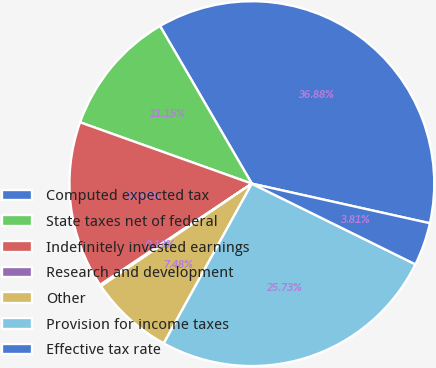Convert chart to OTSL. <chart><loc_0><loc_0><loc_500><loc_500><pie_chart><fcel>Computed expected tax<fcel>State taxes net of federal<fcel>Indefinitely invested earnings<fcel>Research and development<fcel>Other<fcel>Provision for income taxes<fcel>Effective tax rate<nl><fcel>36.88%<fcel>11.15%<fcel>14.83%<fcel>0.13%<fcel>7.48%<fcel>25.73%<fcel>3.81%<nl></chart> 